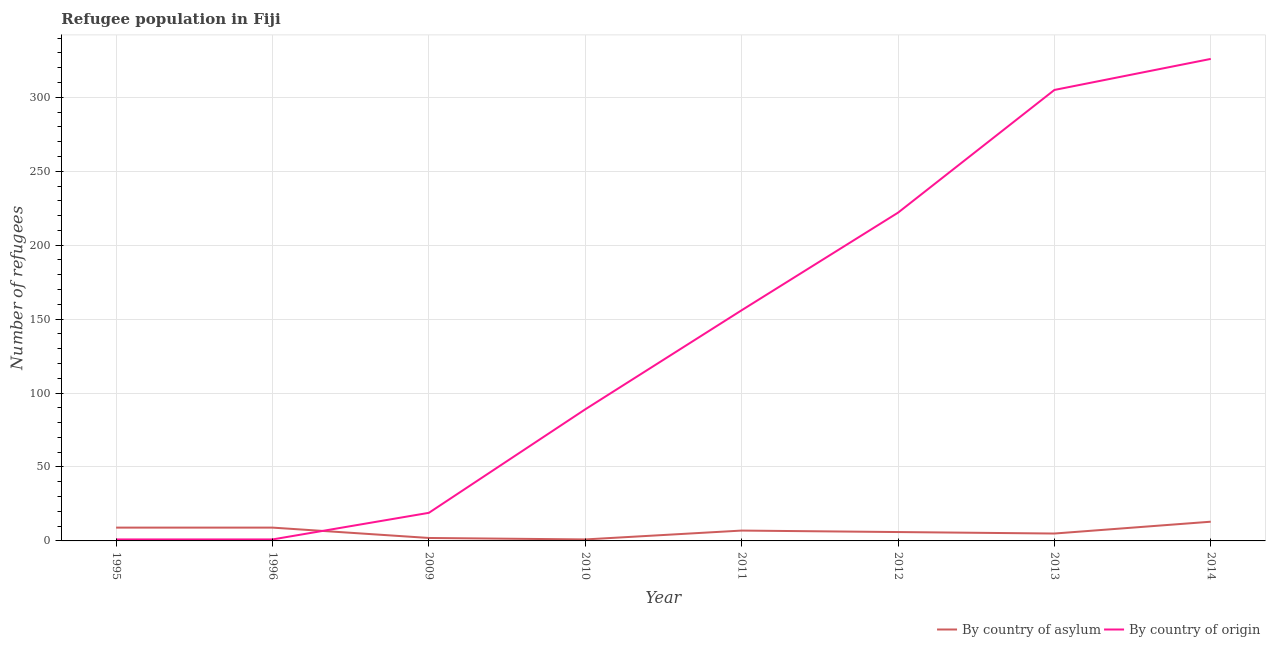How many different coloured lines are there?
Your answer should be very brief. 2. Does the line corresponding to number of refugees by country of origin intersect with the line corresponding to number of refugees by country of asylum?
Offer a very short reply. Yes. What is the number of refugees by country of origin in 2011?
Keep it short and to the point. 156. Across all years, what is the maximum number of refugees by country of asylum?
Your answer should be very brief. 13. Across all years, what is the minimum number of refugees by country of asylum?
Ensure brevity in your answer.  1. What is the total number of refugees by country of asylum in the graph?
Keep it short and to the point. 52. What is the difference between the number of refugees by country of asylum in 2009 and that in 2011?
Make the answer very short. -5. What is the difference between the number of refugees by country of origin in 2012 and the number of refugees by country of asylum in 2010?
Your answer should be very brief. 221. What is the average number of refugees by country of origin per year?
Make the answer very short. 139.88. In the year 2010, what is the difference between the number of refugees by country of asylum and number of refugees by country of origin?
Make the answer very short. -88. In how many years, is the number of refugees by country of origin greater than 310?
Provide a short and direct response. 1. What is the ratio of the number of refugees by country of asylum in 1995 to that in 2009?
Your response must be concise. 4.5. Is the difference between the number of refugees by country of asylum in 1995 and 2010 greater than the difference between the number of refugees by country of origin in 1995 and 2010?
Make the answer very short. Yes. What is the difference between the highest and the lowest number of refugees by country of origin?
Your response must be concise. 325. Does the number of refugees by country of asylum monotonically increase over the years?
Offer a very short reply. No. Is the number of refugees by country of asylum strictly greater than the number of refugees by country of origin over the years?
Offer a terse response. No. Is the number of refugees by country of asylum strictly less than the number of refugees by country of origin over the years?
Provide a succinct answer. No. How many years are there in the graph?
Provide a succinct answer. 8. Are the values on the major ticks of Y-axis written in scientific E-notation?
Offer a terse response. No. Does the graph contain any zero values?
Give a very brief answer. No. How are the legend labels stacked?
Ensure brevity in your answer.  Horizontal. What is the title of the graph?
Make the answer very short. Refugee population in Fiji. Does "Private funds" appear as one of the legend labels in the graph?
Your answer should be compact. No. What is the label or title of the Y-axis?
Provide a succinct answer. Number of refugees. What is the Number of refugees of By country of asylum in 1995?
Provide a short and direct response. 9. What is the Number of refugees of By country of asylum in 2009?
Your answer should be very brief. 2. What is the Number of refugees in By country of origin in 2010?
Give a very brief answer. 89. What is the Number of refugees in By country of origin in 2011?
Your response must be concise. 156. What is the Number of refugees in By country of asylum in 2012?
Ensure brevity in your answer.  6. What is the Number of refugees in By country of origin in 2012?
Give a very brief answer. 222. What is the Number of refugees in By country of asylum in 2013?
Provide a short and direct response. 5. What is the Number of refugees in By country of origin in 2013?
Make the answer very short. 305. What is the Number of refugees of By country of asylum in 2014?
Provide a short and direct response. 13. What is the Number of refugees of By country of origin in 2014?
Your answer should be compact. 326. Across all years, what is the maximum Number of refugees of By country of asylum?
Offer a terse response. 13. Across all years, what is the maximum Number of refugees of By country of origin?
Your response must be concise. 326. Across all years, what is the minimum Number of refugees of By country of origin?
Provide a succinct answer. 1. What is the total Number of refugees in By country of origin in the graph?
Offer a very short reply. 1119. What is the difference between the Number of refugees of By country of origin in 1995 and that in 1996?
Offer a terse response. 0. What is the difference between the Number of refugees of By country of origin in 1995 and that in 2009?
Offer a very short reply. -18. What is the difference between the Number of refugees in By country of asylum in 1995 and that in 2010?
Make the answer very short. 8. What is the difference between the Number of refugees in By country of origin in 1995 and that in 2010?
Provide a succinct answer. -88. What is the difference between the Number of refugees in By country of origin in 1995 and that in 2011?
Provide a succinct answer. -155. What is the difference between the Number of refugees of By country of asylum in 1995 and that in 2012?
Keep it short and to the point. 3. What is the difference between the Number of refugees in By country of origin in 1995 and that in 2012?
Offer a terse response. -221. What is the difference between the Number of refugees of By country of asylum in 1995 and that in 2013?
Give a very brief answer. 4. What is the difference between the Number of refugees of By country of origin in 1995 and that in 2013?
Provide a short and direct response. -304. What is the difference between the Number of refugees of By country of origin in 1995 and that in 2014?
Provide a succinct answer. -325. What is the difference between the Number of refugees in By country of origin in 1996 and that in 2010?
Keep it short and to the point. -88. What is the difference between the Number of refugees of By country of asylum in 1996 and that in 2011?
Give a very brief answer. 2. What is the difference between the Number of refugees in By country of origin in 1996 and that in 2011?
Your answer should be compact. -155. What is the difference between the Number of refugees of By country of asylum in 1996 and that in 2012?
Offer a very short reply. 3. What is the difference between the Number of refugees in By country of origin in 1996 and that in 2012?
Your answer should be very brief. -221. What is the difference between the Number of refugees in By country of asylum in 1996 and that in 2013?
Offer a terse response. 4. What is the difference between the Number of refugees in By country of origin in 1996 and that in 2013?
Your answer should be very brief. -304. What is the difference between the Number of refugees of By country of asylum in 1996 and that in 2014?
Keep it short and to the point. -4. What is the difference between the Number of refugees of By country of origin in 1996 and that in 2014?
Ensure brevity in your answer.  -325. What is the difference between the Number of refugees of By country of asylum in 2009 and that in 2010?
Offer a very short reply. 1. What is the difference between the Number of refugees in By country of origin in 2009 and that in 2010?
Make the answer very short. -70. What is the difference between the Number of refugees of By country of asylum in 2009 and that in 2011?
Your answer should be compact. -5. What is the difference between the Number of refugees in By country of origin in 2009 and that in 2011?
Provide a succinct answer. -137. What is the difference between the Number of refugees of By country of origin in 2009 and that in 2012?
Provide a succinct answer. -203. What is the difference between the Number of refugees in By country of asylum in 2009 and that in 2013?
Ensure brevity in your answer.  -3. What is the difference between the Number of refugees of By country of origin in 2009 and that in 2013?
Ensure brevity in your answer.  -286. What is the difference between the Number of refugees of By country of asylum in 2009 and that in 2014?
Your response must be concise. -11. What is the difference between the Number of refugees of By country of origin in 2009 and that in 2014?
Your answer should be very brief. -307. What is the difference between the Number of refugees in By country of asylum in 2010 and that in 2011?
Keep it short and to the point. -6. What is the difference between the Number of refugees of By country of origin in 2010 and that in 2011?
Your answer should be compact. -67. What is the difference between the Number of refugees in By country of origin in 2010 and that in 2012?
Offer a terse response. -133. What is the difference between the Number of refugees in By country of asylum in 2010 and that in 2013?
Your response must be concise. -4. What is the difference between the Number of refugees of By country of origin in 2010 and that in 2013?
Give a very brief answer. -216. What is the difference between the Number of refugees of By country of origin in 2010 and that in 2014?
Your answer should be very brief. -237. What is the difference between the Number of refugees of By country of origin in 2011 and that in 2012?
Give a very brief answer. -66. What is the difference between the Number of refugees of By country of asylum in 2011 and that in 2013?
Provide a short and direct response. 2. What is the difference between the Number of refugees in By country of origin in 2011 and that in 2013?
Make the answer very short. -149. What is the difference between the Number of refugees of By country of asylum in 2011 and that in 2014?
Your response must be concise. -6. What is the difference between the Number of refugees of By country of origin in 2011 and that in 2014?
Your answer should be very brief. -170. What is the difference between the Number of refugees in By country of origin in 2012 and that in 2013?
Give a very brief answer. -83. What is the difference between the Number of refugees of By country of asylum in 2012 and that in 2014?
Offer a terse response. -7. What is the difference between the Number of refugees in By country of origin in 2012 and that in 2014?
Offer a very short reply. -104. What is the difference between the Number of refugees in By country of asylum in 2013 and that in 2014?
Give a very brief answer. -8. What is the difference between the Number of refugees of By country of origin in 2013 and that in 2014?
Ensure brevity in your answer.  -21. What is the difference between the Number of refugees of By country of asylum in 1995 and the Number of refugees of By country of origin in 1996?
Your answer should be very brief. 8. What is the difference between the Number of refugees of By country of asylum in 1995 and the Number of refugees of By country of origin in 2009?
Provide a short and direct response. -10. What is the difference between the Number of refugees in By country of asylum in 1995 and the Number of refugees in By country of origin in 2010?
Provide a short and direct response. -80. What is the difference between the Number of refugees of By country of asylum in 1995 and the Number of refugees of By country of origin in 2011?
Ensure brevity in your answer.  -147. What is the difference between the Number of refugees of By country of asylum in 1995 and the Number of refugees of By country of origin in 2012?
Provide a succinct answer. -213. What is the difference between the Number of refugees in By country of asylum in 1995 and the Number of refugees in By country of origin in 2013?
Your answer should be very brief. -296. What is the difference between the Number of refugees of By country of asylum in 1995 and the Number of refugees of By country of origin in 2014?
Offer a terse response. -317. What is the difference between the Number of refugees of By country of asylum in 1996 and the Number of refugees of By country of origin in 2009?
Give a very brief answer. -10. What is the difference between the Number of refugees of By country of asylum in 1996 and the Number of refugees of By country of origin in 2010?
Offer a terse response. -80. What is the difference between the Number of refugees of By country of asylum in 1996 and the Number of refugees of By country of origin in 2011?
Make the answer very short. -147. What is the difference between the Number of refugees in By country of asylum in 1996 and the Number of refugees in By country of origin in 2012?
Keep it short and to the point. -213. What is the difference between the Number of refugees of By country of asylum in 1996 and the Number of refugees of By country of origin in 2013?
Your answer should be very brief. -296. What is the difference between the Number of refugees of By country of asylum in 1996 and the Number of refugees of By country of origin in 2014?
Your response must be concise. -317. What is the difference between the Number of refugees of By country of asylum in 2009 and the Number of refugees of By country of origin in 2010?
Give a very brief answer. -87. What is the difference between the Number of refugees in By country of asylum in 2009 and the Number of refugees in By country of origin in 2011?
Offer a very short reply. -154. What is the difference between the Number of refugees in By country of asylum in 2009 and the Number of refugees in By country of origin in 2012?
Provide a succinct answer. -220. What is the difference between the Number of refugees in By country of asylum in 2009 and the Number of refugees in By country of origin in 2013?
Give a very brief answer. -303. What is the difference between the Number of refugees in By country of asylum in 2009 and the Number of refugees in By country of origin in 2014?
Offer a terse response. -324. What is the difference between the Number of refugees in By country of asylum in 2010 and the Number of refugees in By country of origin in 2011?
Make the answer very short. -155. What is the difference between the Number of refugees of By country of asylum in 2010 and the Number of refugees of By country of origin in 2012?
Provide a succinct answer. -221. What is the difference between the Number of refugees of By country of asylum in 2010 and the Number of refugees of By country of origin in 2013?
Give a very brief answer. -304. What is the difference between the Number of refugees of By country of asylum in 2010 and the Number of refugees of By country of origin in 2014?
Ensure brevity in your answer.  -325. What is the difference between the Number of refugees in By country of asylum in 2011 and the Number of refugees in By country of origin in 2012?
Give a very brief answer. -215. What is the difference between the Number of refugees in By country of asylum in 2011 and the Number of refugees in By country of origin in 2013?
Keep it short and to the point. -298. What is the difference between the Number of refugees of By country of asylum in 2011 and the Number of refugees of By country of origin in 2014?
Give a very brief answer. -319. What is the difference between the Number of refugees in By country of asylum in 2012 and the Number of refugees in By country of origin in 2013?
Make the answer very short. -299. What is the difference between the Number of refugees of By country of asylum in 2012 and the Number of refugees of By country of origin in 2014?
Make the answer very short. -320. What is the difference between the Number of refugees of By country of asylum in 2013 and the Number of refugees of By country of origin in 2014?
Keep it short and to the point. -321. What is the average Number of refugees of By country of asylum per year?
Make the answer very short. 6.5. What is the average Number of refugees in By country of origin per year?
Your response must be concise. 139.88. In the year 2010, what is the difference between the Number of refugees of By country of asylum and Number of refugees of By country of origin?
Offer a terse response. -88. In the year 2011, what is the difference between the Number of refugees in By country of asylum and Number of refugees in By country of origin?
Provide a succinct answer. -149. In the year 2012, what is the difference between the Number of refugees in By country of asylum and Number of refugees in By country of origin?
Provide a succinct answer. -216. In the year 2013, what is the difference between the Number of refugees in By country of asylum and Number of refugees in By country of origin?
Your response must be concise. -300. In the year 2014, what is the difference between the Number of refugees of By country of asylum and Number of refugees of By country of origin?
Your answer should be very brief. -313. What is the ratio of the Number of refugees in By country of asylum in 1995 to that in 1996?
Offer a very short reply. 1. What is the ratio of the Number of refugees in By country of origin in 1995 to that in 1996?
Make the answer very short. 1. What is the ratio of the Number of refugees in By country of origin in 1995 to that in 2009?
Provide a succinct answer. 0.05. What is the ratio of the Number of refugees in By country of origin in 1995 to that in 2010?
Ensure brevity in your answer.  0.01. What is the ratio of the Number of refugees in By country of asylum in 1995 to that in 2011?
Ensure brevity in your answer.  1.29. What is the ratio of the Number of refugees of By country of origin in 1995 to that in 2011?
Offer a terse response. 0.01. What is the ratio of the Number of refugees in By country of asylum in 1995 to that in 2012?
Provide a succinct answer. 1.5. What is the ratio of the Number of refugees of By country of origin in 1995 to that in 2012?
Offer a terse response. 0. What is the ratio of the Number of refugees in By country of origin in 1995 to that in 2013?
Ensure brevity in your answer.  0. What is the ratio of the Number of refugees in By country of asylum in 1995 to that in 2014?
Keep it short and to the point. 0.69. What is the ratio of the Number of refugees in By country of origin in 1995 to that in 2014?
Your answer should be very brief. 0. What is the ratio of the Number of refugees in By country of origin in 1996 to that in 2009?
Your answer should be very brief. 0.05. What is the ratio of the Number of refugees in By country of origin in 1996 to that in 2010?
Give a very brief answer. 0.01. What is the ratio of the Number of refugees in By country of origin in 1996 to that in 2011?
Offer a terse response. 0.01. What is the ratio of the Number of refugees in By country of origin in 1996 to that in 2012?
Offer a terse response. 0. What is the ratio of the Number of refugees in By country of origin in 1996 to that in 2013?
Offer a very short reply. 0. What is the ratio of the Number of refugees in By country of asylum in 1996 to that in 2014?
Your answer should be very brief. 0.69. What is the ratio of the Number of refugees of By country of origin in 1996 to that in 2014?
Your response must be concise. 0. What is the ratio of the Number of refugees of By country of origin in 2009 to that in 2010?
Provide a short and direct response. 0.21. What is the ratio of the Number of refugees of By country of asylum in 2009 to that in 2011?
Provide a short and direct response. 0.29. What is the ratio of the Number of refugees in By country of origin in 2009 to that in 2011?
Your response must be concise. 0.12. What is the ratio of the Number of refugees in By country of origin in 2009 to that in 2012?
Ensure brevity in your answer.  0.09. What is the ratio of the Number of refugees in By country of origin in 2009 to that in 2013?
Your answer should be very brief. 0.06. What is the ratio of the Number of refugees in By country of asylum in 2009 to that in 2014?
Give a very brief answer. 0.15. What is the ratio of the Number of refugees of By country of origin in 2009 to that in 2014?
Make the answer very short. 0.06. What is the ratio of the Number of refugees in By country of asylum in 2010 to that in 2011?
Provide a short and direct response. 0.14. What is the ratio of the Number of refugees in By country of origin in 2010 to that in 2011?
Your response must be concise. 0.57. What is the ratio of the Number of refugees in By country of asylum in 2010 to that in 2012?
Your answer should be very brief. 0.17. What is the ratio of the Number of refugees of By country of origin in 2010 to that in 2012?
Make the answer very short. 0.4. What is the ratio of the Number of refugees in By country of asylum in 2010 to that in 2013?
Your answer should be very brief. 0.2. What is the ratio of the Number of refugees in By country of origin in 2010 to that in 2013?
Your response must be concise. 0.29. What is the ratio of the Number of refugees of By country of asylum in 2010 to that in 2014?
Give a very brief answer. 0.08. What is the ratio of the Number of refugees in By country of origin in 2010 to that in 2014?
Provide a short and direct response. 0.27. What is the ratio of the Number of refugees in By country of asylum in 2011 to that in 2012?
Your response must be concise. 1.17. What is the ratio of the Number of refugees of By country of origin in 2011 to that in 2012?
Provide a short and direct response. 0.7. What is the ratio of the Number of refugees of By country of asylum in 2011 to that in 2013?
Make the answer very short. 1.4. What is the ratio of the Number of refugees of By country of origin in 2011 to that in 2013?
Give a very brief answer. 0.51. What is the ratio of the Number of refugees in By country of asylum in 2011 to that in 2014?
Provide a succinct answer. 0.54. What is the ratio of the Number of refugees in By country of origin in 2011 to that in 2014?
Provide a short and direct response. 0.48. What is the ratio of the Number of refugees of By country of asylum in 2012 to that in 2013?
Offer a terse response. 1.2. What is the ratio of the Number of refugees of By country of origin in 2012 to that in 2013?
Your answer should be compact. 0.73. What is the ratio of the Number of refugees in By country of asylum in 2012 to that in 2014?
Make the answer very short. 0.46. What is the ratio of the Number of refugees of By country of origin in 2012 to that in 2014?
Your answer should be very brief. 0.68. What is the ratio of the Number of refugees of By country of asylum in 2013 to that in 2014?
Your answer should be compact. 0.38. What is the ratio of the Number of refugees in By country of origin in 2013 to that in 2014?
Your answer should be very brief. 0.94. What is the difference between the highest and the lowest Number of refugees of By country of asylum?
Ensure brevity in your answer.  12. What is the difference between the highest and the lowest Number of refugees in By country of origin?
Give a very brief answer. 325. 